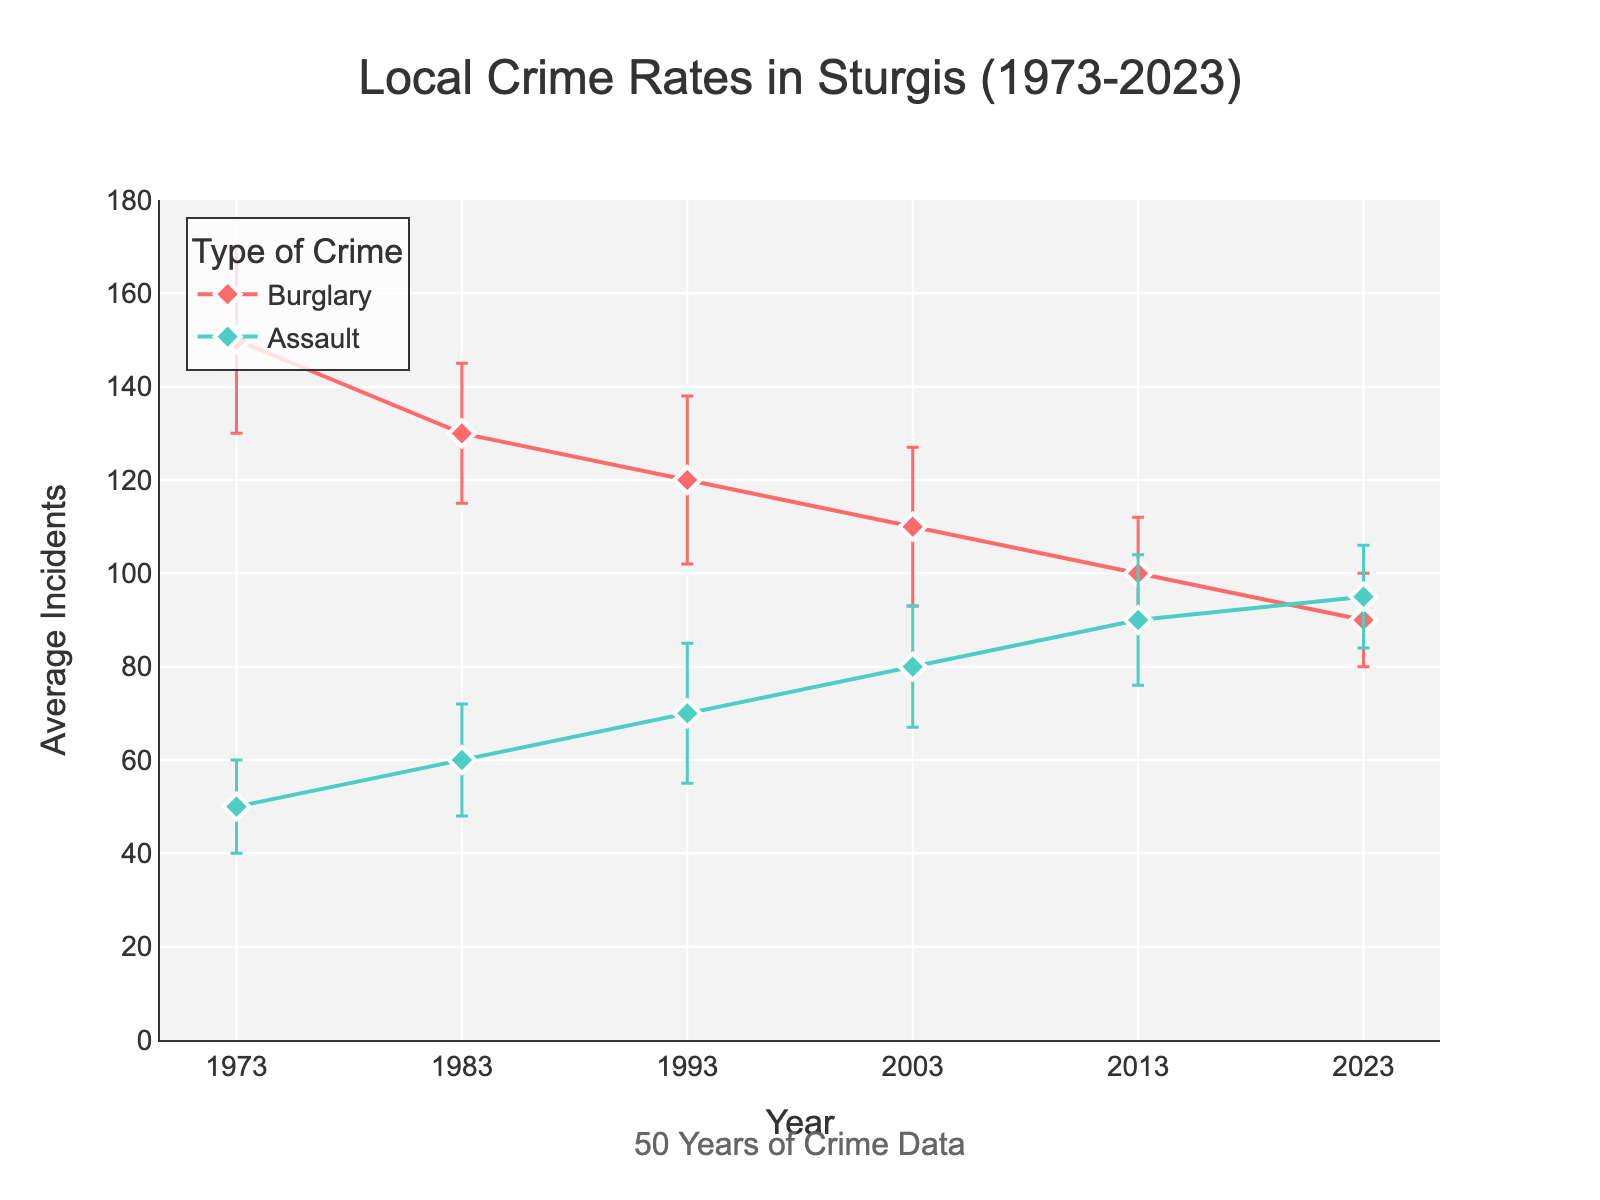What is the title of the plot? The title is usually displayed at the top center of the plot in a prominent and larger font size. From the title, you can see it describes the subject and time range of the data.
Answer: Local Crime Rates in Sturgis (1973-2023) How many types of crime are shown in the plot? The legend to the right or the symbols used in the plot indicate the types of crimes tracked. Each type of crime has a unique color and marker.
Answer: 2 (Burglary and Assault) Which type of crime had the highest average incidents in 1973? Look at the markers for the year 1973 on the x-axis and compare the y-values for the different crime types.
Answer: Burglary Between which two decades did the average number of burglaries decrease the most? Compare the difference in average incidents of burglaries between each consecutive decade and find the one with the largest decrease.
Answer: 1983-1993 In which year was the standard deviation for assaults highest? Check the error bars associated with assault markers across all years. The larger the error bar, the higher the standard deviation.
Answer: 1993 What is the trend of average burglary incidents over the five decades? Observe the overall movement of the burglary line from 1973 to 2023 to determine whether it is increasing, decreasing, or stable.
Answer: Decreasing Which crime type shows a general increasing trend over the past 50 years? Observe the overall movement of both lines from 1973 to 2023 and identify which one shows an upward trend.
Answer: Assault Compare the average incidents of burglary and assault in 2023. Which is higher and by how much? Find the y-values for burglary and assault in 2023 and subtract the smaller from the larger.
Answer: Assault is higher by 5 incidents What is the average number of assault incidents over the five decades? Sum the average incidents of assault for each decade and divide by the number of decades to find the mean.
Answer: (50 + 60 + 70 + 80 + 90 + 95) / 6 = 74.17 Which type of crime had more variability across the decades? Compare the lengths of the error bars across all years for both types of crimes. The type with longer error bars has more variability.
Answer: Assault 